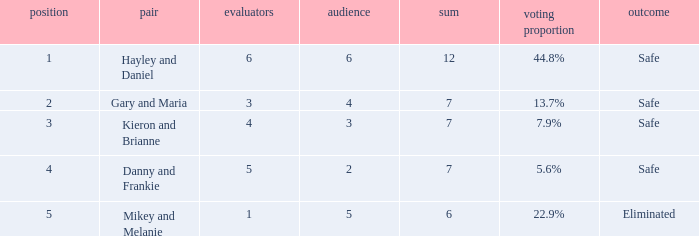What was the result for the total of 12? Safe. 